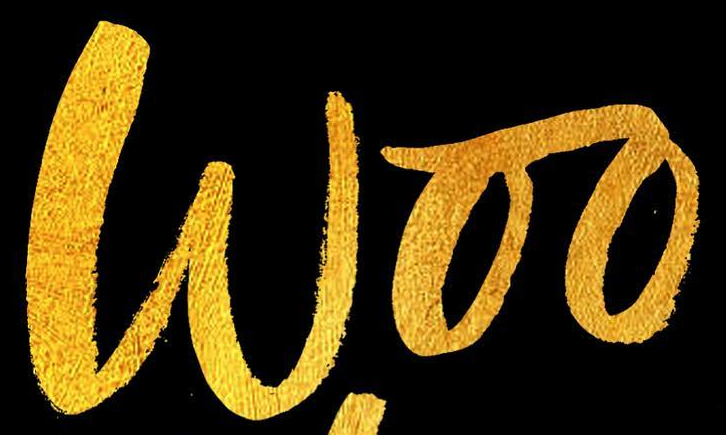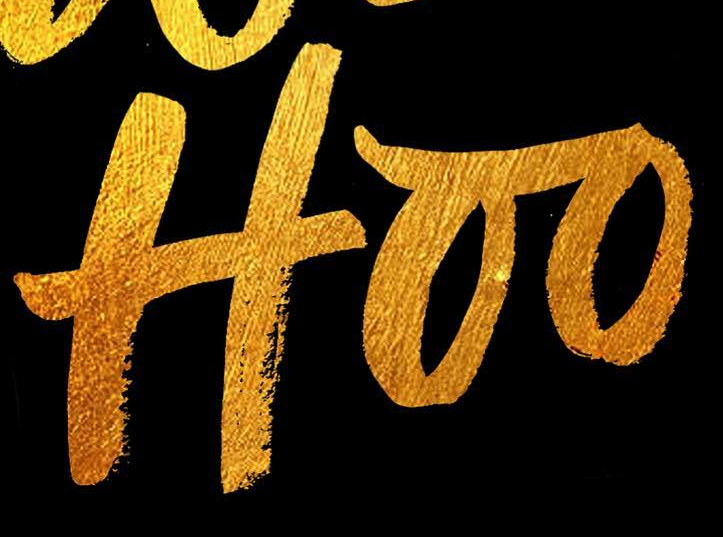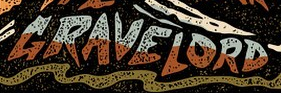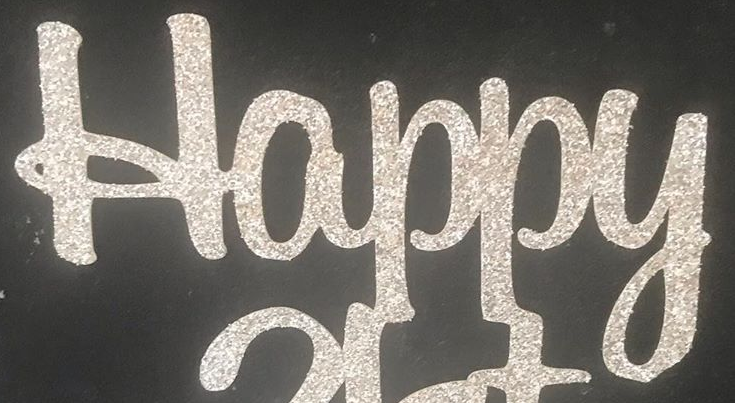Transcribe the words shown in these images in order, separated by a semicolon. Woo; Hoo; GRAVELORD; Happy 